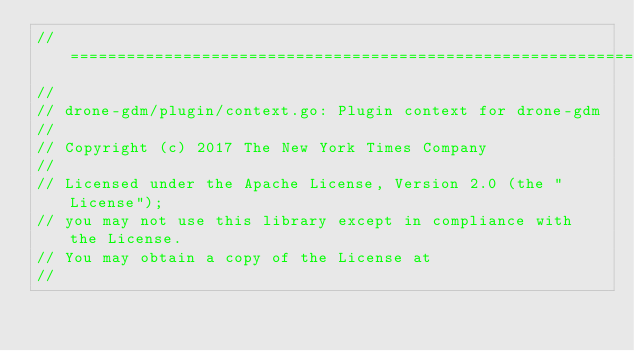<code> <loc_0><loc_0><loc_500><loc_500><_Go_>//==============================================================================
//
// drone-gdm/plugin/context.go: Plugin context for drone-gdm
//
// Copyright (c) 2017 The New York Times Company
//
// Licensed under the Apache License, Version 2.0 (the "License");
// you may not use this library except in compliance with the License.
// You may obtain a copy of the License at
//</code> 